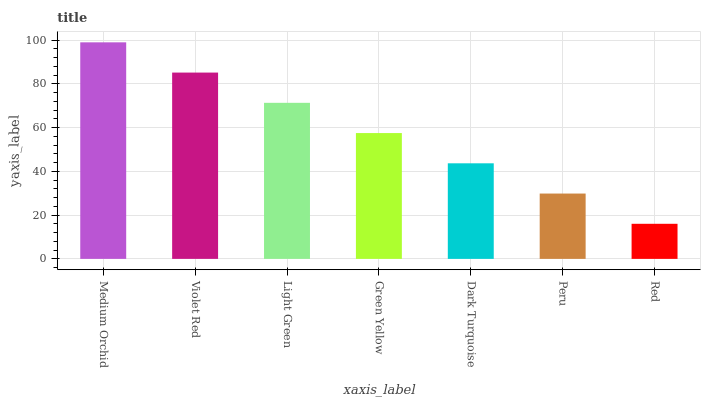Is Red the minimum?
Answer yes or no. Yes. Is Medium Orchid the maximum?
Answer yes or no. Yes. Is Violet Red the minimum?
Answer yes or no. No. Is Violet Red the maximum?
Answer yes or no. No. Is Medium Orchid greater than Violet Red?
Answer yes or no. Yes. Is Violet Red less than Medium Orchid?
Answer yes or no. Yes. Is Violet Red greater than Medium Orchid?
Answer yes or no. No. Is Medium Orchid less than Violet Red?
Answer yes or no. No. Is Green Yellow the high median?
Answer yes or no. Yes. Is Green Yellow the low median?
Answer yes or no. Yes. Is Light Green the high median?
Answer yes or no. No. Is Medium Orchid the low median?
Answer yes or no. No. 